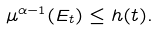<formula> <loc_0><loc_0><loc_500><loc_500>\mu ^ { \alpha - 1 } ( E _ { t } ) \leq h ( t ) .</formula> 